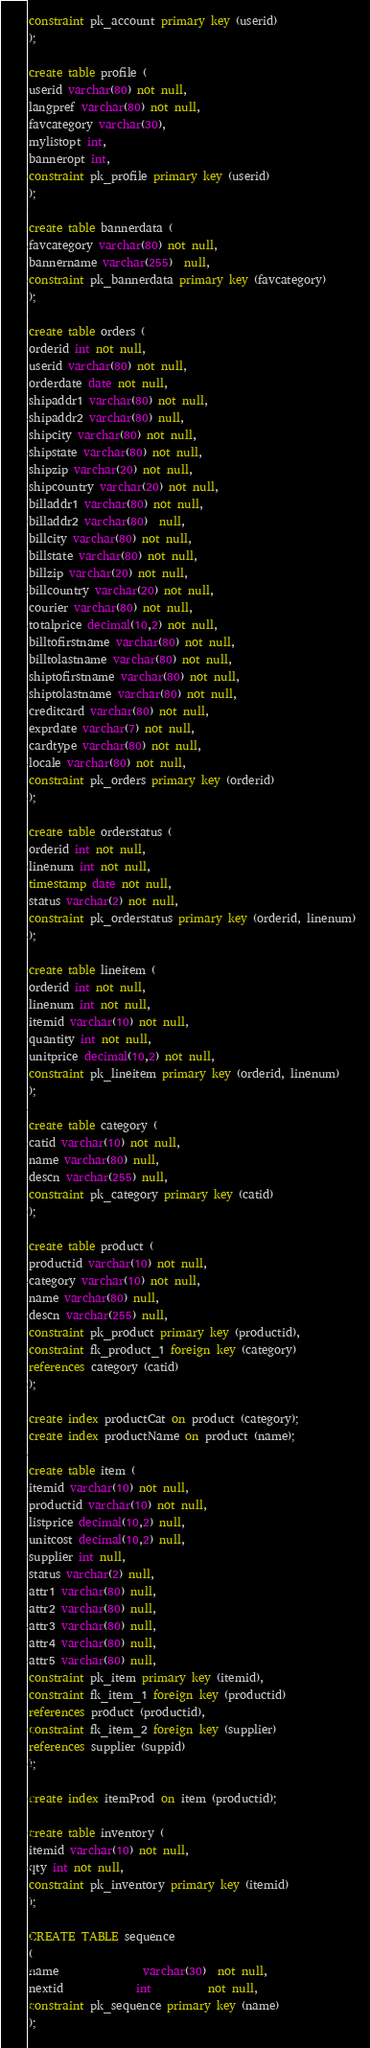<code> <loc_0><loc_0><loc_500><loc_500><_SQL_>constraint pk_account primary key (userid)
);

create table profile (
userid varchar(80) not null,
langpref varchar(80) not null,
favcategory varchar(30),
mylistopt int,
banneropt int,
constraint pk_profile primary key (userid)
);

create table bannerdata (
favcategory varchar(80) not null,
bannername varchar(255)  null,
constraint pk_bannerdata primary key (favcategory)
);

create table orders (
orderid int not null,
userid varchar(80) not null,
orderdate date not null,
shipaddr1 varchar(80) not null,
shipaddr2 varchar(80) null,
shipcity varchar(80) not null,
shipstate varchar(80) not null,
shipzip varchar(20) not null,
shipcountry varchar(20) not null,
billaddr1 varchar(80) not null,
billaddr2 varchar(80)  null,
billcity varchar(80) not null,
billstate varchar(80) not null,
billzip varchar(20) not null,
billcountry varchar(20) not null,
courier varchar(80) not null,
totalprice decimal(10,2) not null,
billtofirstname varchar(80) not null,
billtolastname varchar(80) not null,
shiptofirstname varchar(80) not null,
shiptolastname varchar(80) not null,
creditcard varchar(80) not null,
exprdate varchar(7) not null,
cardtype varchar(80) not null,
locale varchar(80) not null,
constraint pk_orders primary key (orderid)
);

create table orderstatus (
orderid int not null,
linenum int not null,
timestamp date not null,
status varchar(2) not null,
constraint pk_orderstatus primary key (orderid, linenum)
);

create table lineitem (
orderid int not null,
linenum int not null,
itemid varchar(10) not null,
quantity int not null,
unitprice decimal(10,2) not null,
constraint pk_lineitem primary key (orderid, linenum)
);

create table category (
catid varchar(10) not null,
name varchar(80) null,
descn varchar(255) null,
constraint pk_category primary key (catid)
);

create table product (
productid varchar(10) not null,
category varchar(10) not null,
name varchar(80) null,
descn varchar(255) null,
constraint pk_product primary key (productid),
constraint fk_product_1 foreign key (category)
references category (catid)
);

create index productCat on product (category);
create index productName on product (name);

create table item (
itemid varchar(10) not null,
productid varchar(10) not null,
listprice decimal(10,2) null,
unitcost decimal(10,2) null,
supplier int null,
status varchar(2) null,
attr1 varchar(80) null,
attr2 varchar(80) null,
attr3 varchar(80) null,
attr4 varchar(80) null,
attr5 varchar(80) null,
constraint pk_item primary key (itemid),
constraint fk_item_1 foreign key (productid)
references product (productid),
constraint fk_item_2 foreign key (supplier)
references supplier (suppid)
);

create index itemProd on item (productid);

create table inventory (
itemid varchar(10) not null,
qty int not null,
constraint pk_inventory primary key (itemid)
);

CREATE TABLE sequence
(
name               varchar(30)  not null,
nextid             int          not null,
constraint pk_sequence primary key (name)
);

</code> 